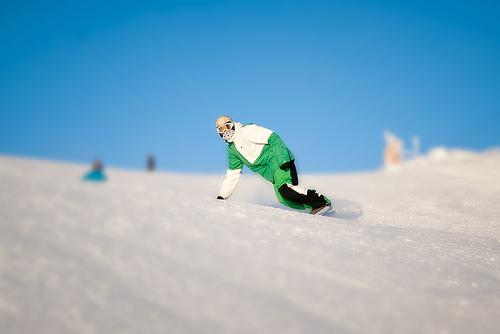Question: what color is the sky?
Choices:
A. Pink.
B. White.
C. Gray.
D. Blue.
Answer with the letter. Answer: D Question: what activity is the man participating in?
Choices:
A. Skiing.
B. Diving.
C. Running.
D. Snowboarding.
Answer with the letter. Answer: D Question: where was this image taken?
Choices:
A. Skiing down the mountain.
B. Next to a pyramid.
C. In the desert.
D. On a water ride.
Answer with the letter. Answer: A 